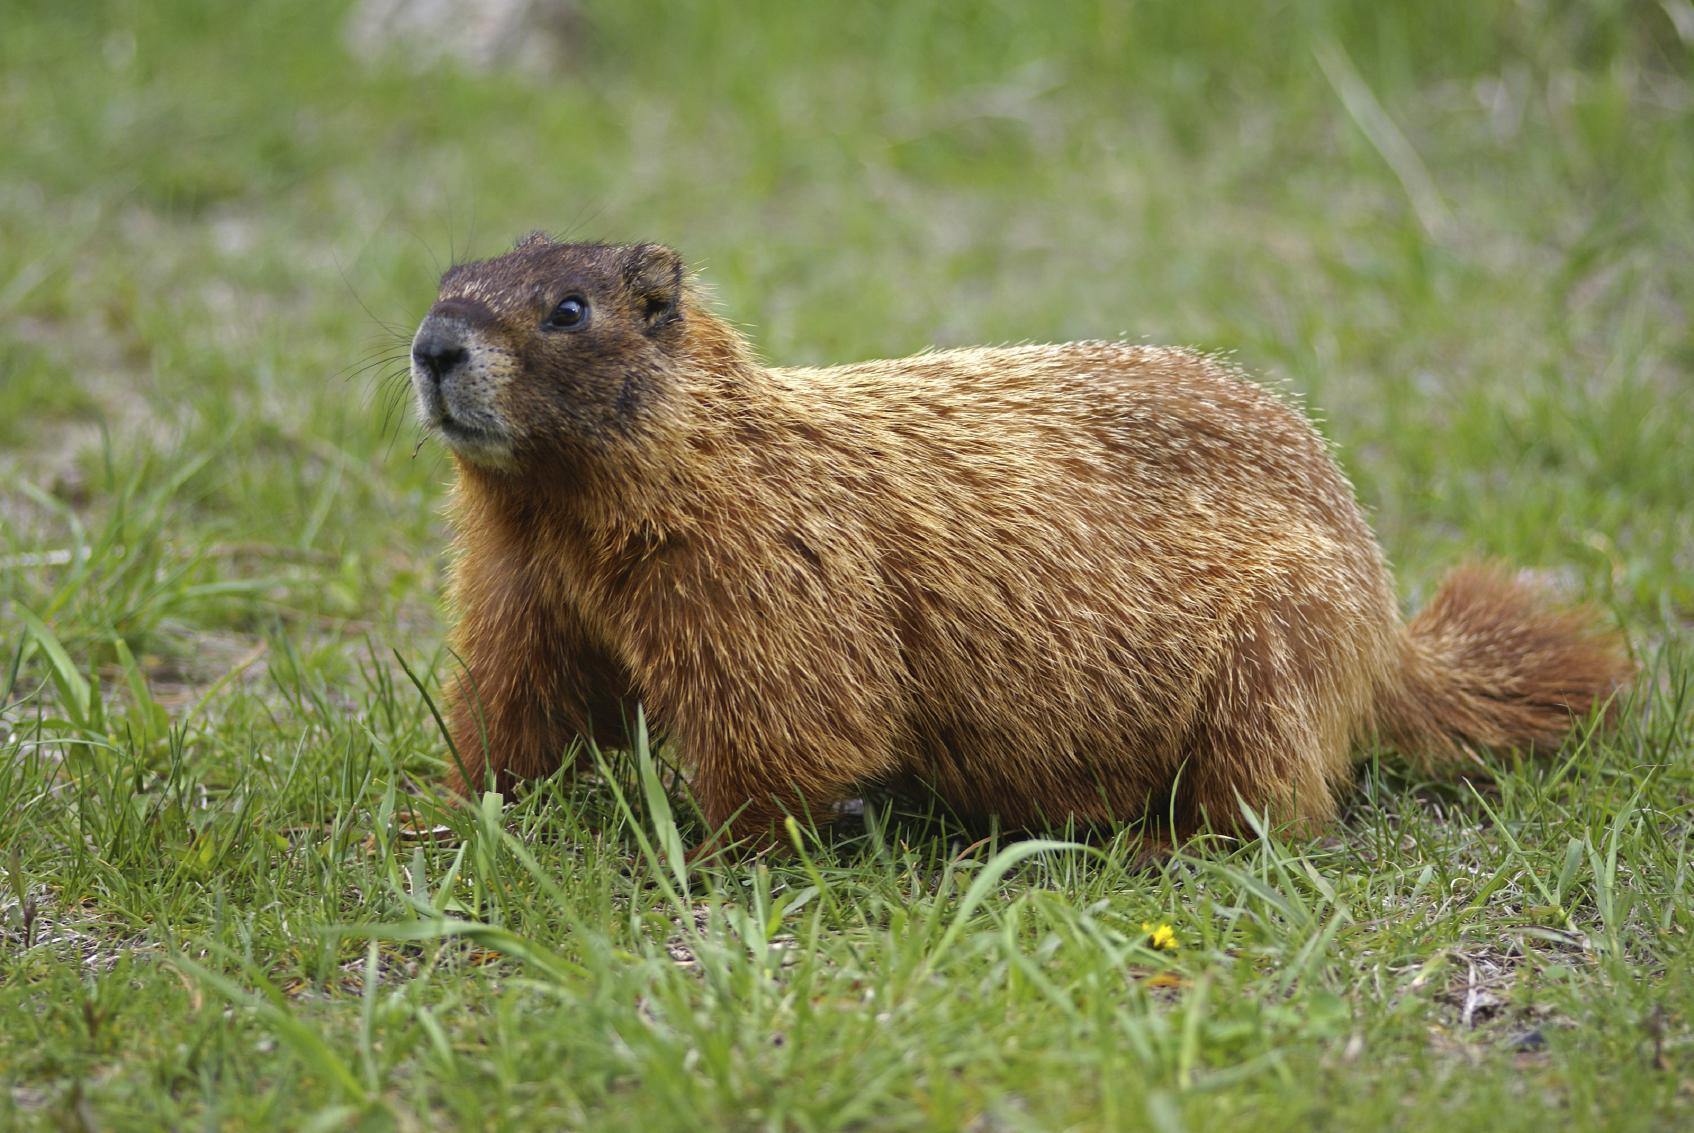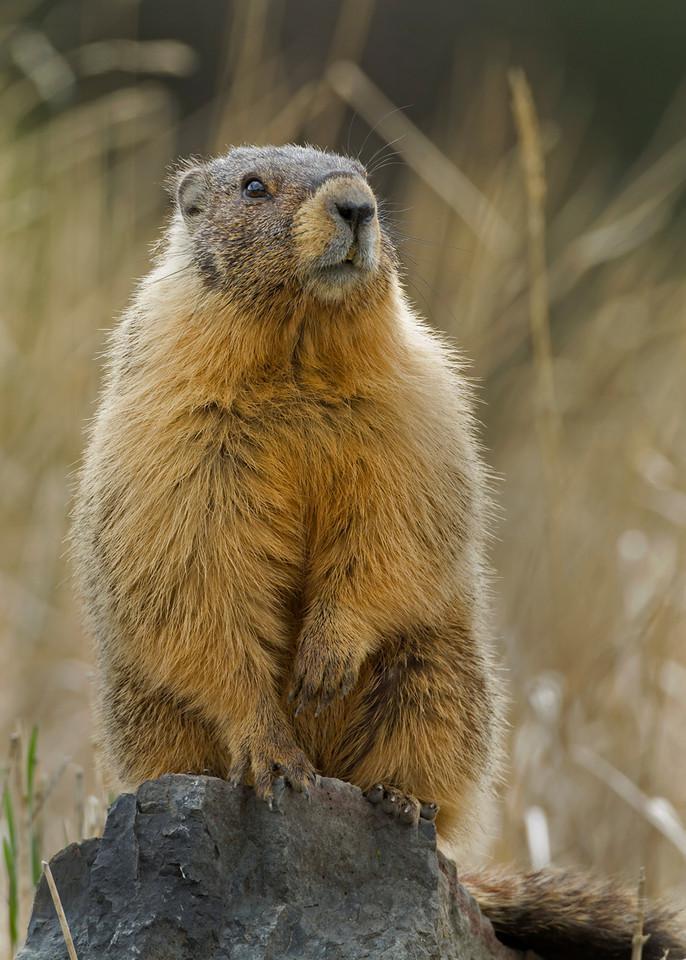The first image is the image on the left, the second image is the image on the right. Analyze the images presented: Is the assertion "The left and right image contains the same number of groundhogs with at least one sitting on their butt." valid? Answer yes or no. Yes. The first image is the image on the left, the second image is the image on the right. For the images shown, is this caption "All marmots shown are standing up on their hind legs, and one image shows a single marmot facing forward." true? Answer yes or no. No. 